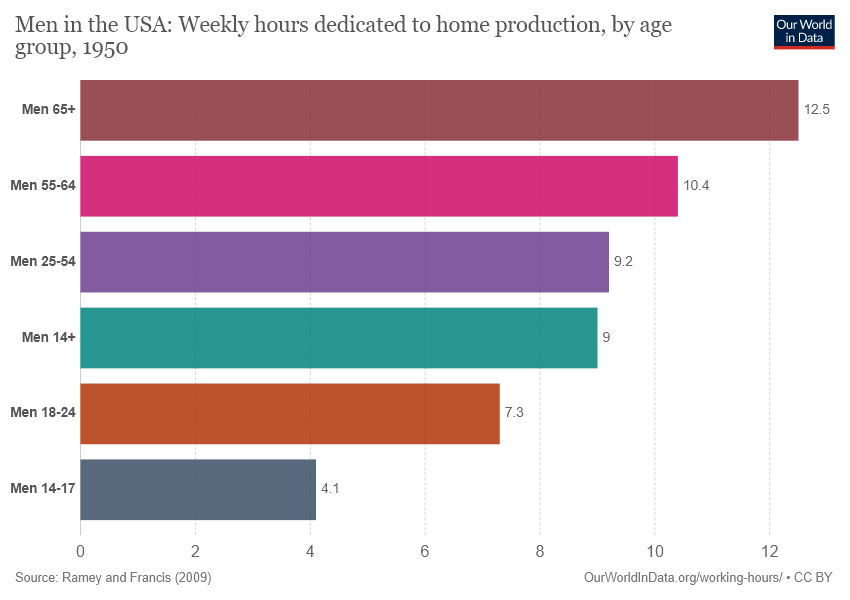Give some essential details in this illustration. The value of the longest bar is 12.5. 